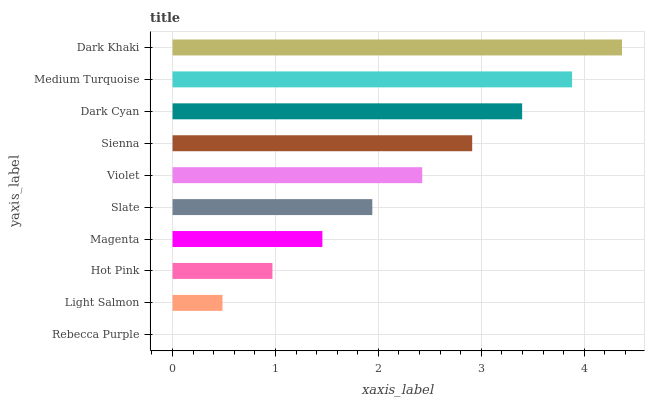Is Rebecca Purple the minimum?
Answer yes or no. Yes. Is Dark Khaki the maximum?
Answer yes or no. Yes. Is Light Salmon the minimum?
Answer yes or no. No. Is Light Salmon the maximum?
Answer yes or no. No. Is Light Salmon greater than Rebecca Purple?
Answer yes or no. Yes. Is Rebecca Purple less than Light Salmon?
Answer yes or no. Yes. Is Rebecca Purple greater than Light Salmon?
Answer yes or no. No. Is Light Salmon less than Rebecca Purple?
Answer yes or no. No. Is Violet the high median?
Answer yes or no. Yes. Is Slate the low median?
Answer yes or no. Yes. Is Rebecca Purple the high median?
Answer yes or no. No. Is Dark Cyan the low median?
Answer yes or no. No. 